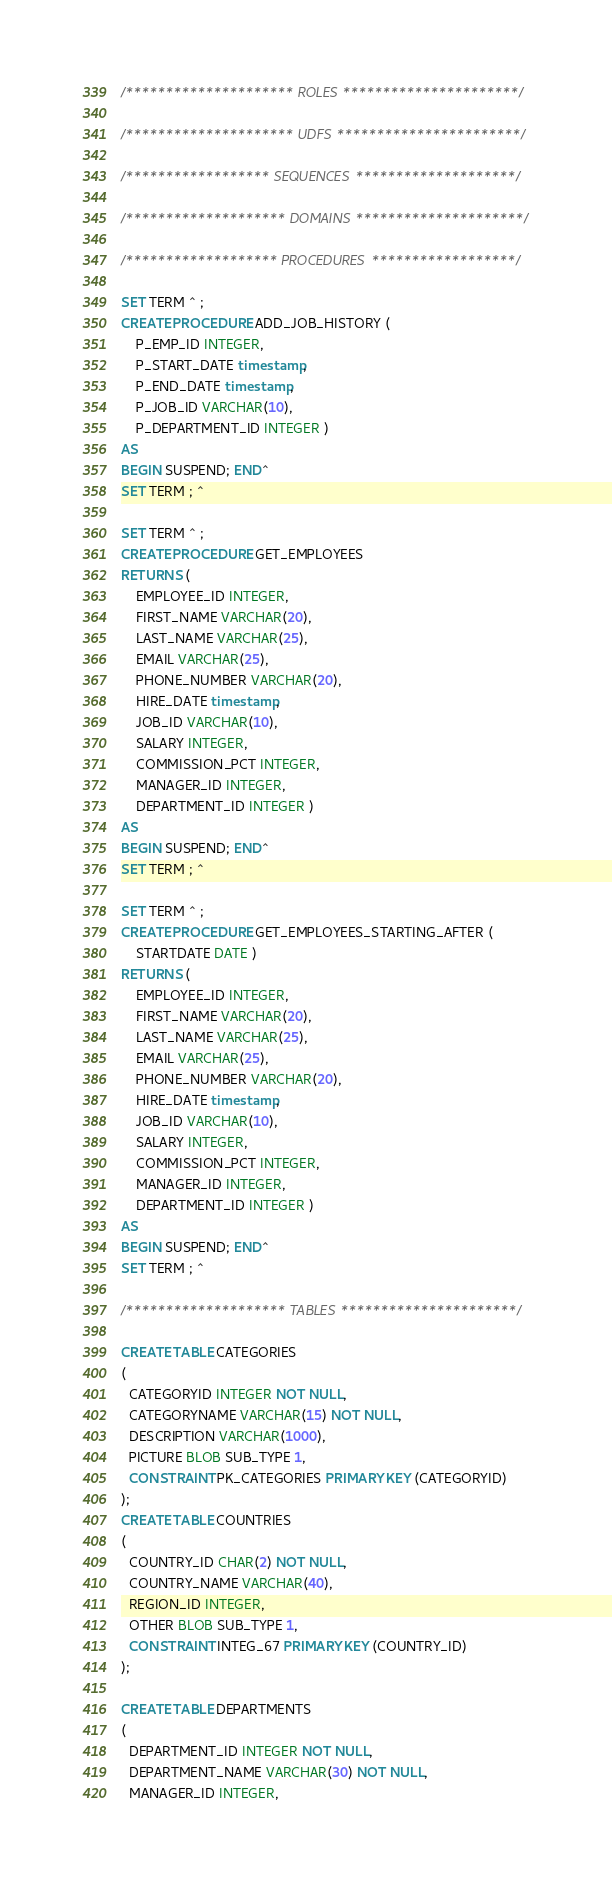Convert code to text. <code><loc_0><loc_0><loc_500><loc_500><_SQL_>/********************* ROLES **********************/

/********************* UDFS ***********************/

/****************** SEQUENCES ********************/

/******************** DOMAINS *********************/

/******************* PROCEDURES ******************/

SET TERM ^ ;
CREATE PROCEDURE ADD_JOB_HISTORY (
    P_EMP_ID INTEGER,
    P_START_DATE timestamp,
    P_END_DATE timestamp,
    P_JOB_ID VARCHAR(10),
    P_DEPARTMENT_ID INTEGER )
AS
BEGIN SUSPEND; END^
SET TERM ; ^

SET TERM ^ ;
CREATE PROCEDURE GET_EMPLOYEES
RETURNS (
    EMPLOYEE_ID INTEGER,
    FIRST_NAME VARCHAR(20),
    LAST_NAME VARCHAR(25),
    EMAIL VARCHAR(25),
    PHONE_NUMBER VARCHAR(20),
    HIRE_DATE timestamp,
    JOB_ID VARCHAR(10),
    SALARY INTEGER,
    COMMISSION_PCT INTEGER,
    MANAGER_ID INTEGER,
    DEPARTMENT_ID INTEGER )
AS
BEGIN SUSPEND; END^
SET TERM ; ^

SET TERM ^ ;
CREATE PROCEDURE GET_EMPLOYEES_STARTING_AFTER (
    STARTDATE DATE )
RETURNS (
    EMPLOYEE_ID INTEGER,
    FIRST_NAME VARCHAR(20),
    LAST_NAME VARCHAR(25),
    EMAIL VARCHAR(25),
    PHONE_NUMBER VARCHAR(20),
    HIRE_DATE timestamp,
    JOB_ID VARCHAR(10),
    SALARY INTEGER,
    COMMISSION_PCT INTEGER,
    MANAGER_ID INTEGER,
    DEPARTMENT_ID INTEGER )
AS
BEGIN SUSPEND; END^
SET TERM ; ^

/******************** TABLES **********************/

CREATE TABLE CATEGORIES
(
  CATEGORYID INTEGER NOT NULL,
  CATEGORYNAME VARCHAR(15) NOT NULL,
  DESCRIPTION VARCHAR(1000),
  PICTURE BLOB SUB_TYPE 1,
  CONSTRAINT PK_CATEGORIES PRIMARY KEY (CATEGORYID)
);
CREATE TABLE COUNTRIES
(
  COUNTRY_ID CHAR(2) NOT NULL,
  COUNTRY_NAME VARCHAR(40),
  REGION_ID INTEGER,
  OTHER BLOB SUB_TYPE 1,
  CONSTRAINT INTEG_67 PRIMARY KEY (COUNTRY_ID)
);

CREATE TABLE DEPARTMENTS
(
  DEPARTMENT_ID INTEGER NOT NULL,
  DEPARTMENT_NAME VARCHAR(30) NOT NULL,
  MANAGER_ID INTEGER,</code> 